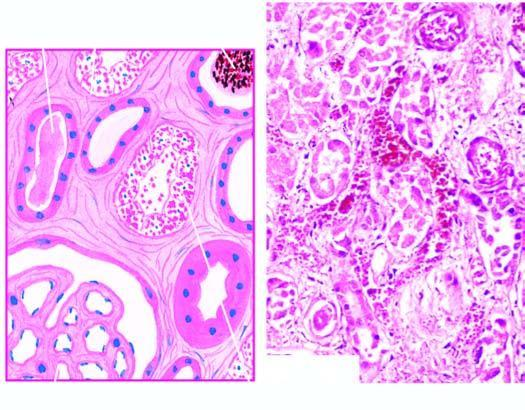re the affected tubules dilated?
Answer the question using a single word or phrase. Yes 